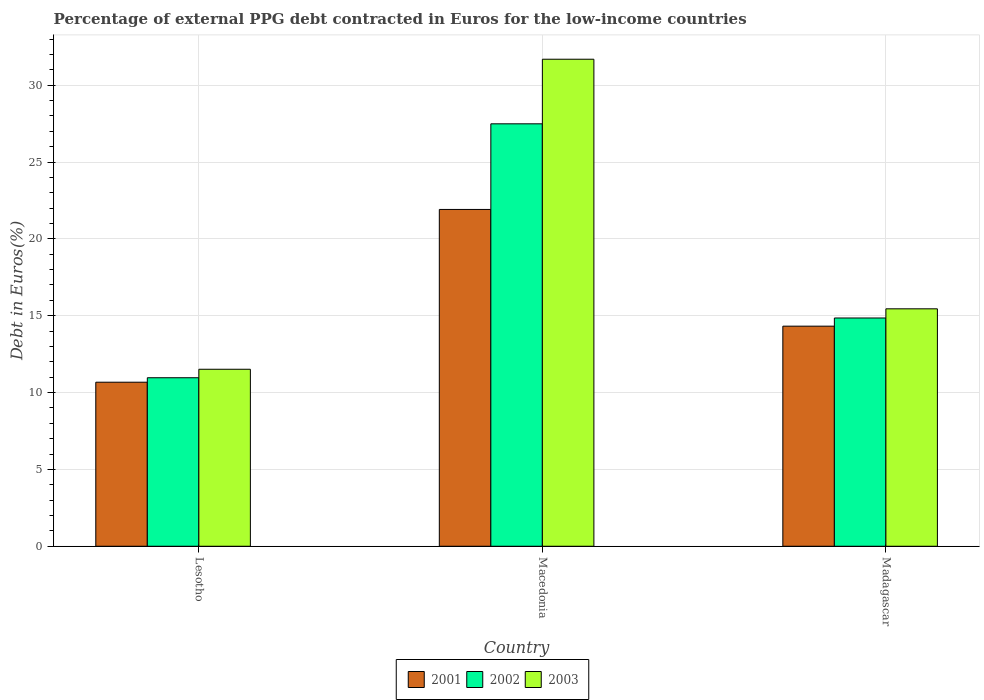How many bars are there on the 2nd tick from the left?
Keep it short and to the point. 3. What is the label of the 3rd group of bars from the left?
Make the answer very short. Madagascar. In how many cases, is the number of bars for a given country not equal to the number of legend labels?
Offer a very short reply. 0. What is the percentage of external PPG debt contracted in Euros in 2003 in Madagascar?
Your answer should be compact. 15.45. Across all countries, what is the maximum percentage of external PPG debt contracted in Euros in 2003?
Your answer should be very brief. 31.69. Across all countries, what is the minimum percentage of external PPG debt contracted in Euros in 2001?
Offer a very short reply. 10.67. In which country was the percentage of external PPG debt contracted in Euros in 2002 maximum?
Keep it short and to the point. Macedonia. In which country was the percentage of external PPG debt contracted in Euros in 2002 minimum?
Keep it short and to the point. Lesotho. What is the total percentage of external PPG debt contracted in Euros in 2002 in the graph?
Provide a succinct answer. 53.3. What is the difference between the percentage of external PPG debt contracted in Euros in 2003 in Lesotho and that in Macedonia?
Offer a terse response. -20.17. What is the difference between the percentage of external PPG debt contracted in Euros in 2001 in Lesotho and the percentage of external PPG debt contracted in Euros in 2003 in Madagascar?
Ensure brevity in your answer.  -4.78. What is the average percentage of external PPG debt contracted in Euros in 2001 per country?
Give a very brief answer. 15.64. What is the difference between the percentage of external PPG debt contracted in Euros of/in 2002 and percentage of external PPG debt contracted in Euros of/in 2001 in Lesotho?
Provide a succinct answer. 0.29. What is the ratio of the percentage of external PPG debt contracted in Euros in 2003 in Lesotho to that in Macedonia?
Offer a very short reply. 0.36. What is the difference between the highest and the second highest percentage of external PPG debt contracted in Euros in 2002?
Make the answer very short. -16.52. What is the difference between the highest and the lowest percentage of external PPG debt contracted in Euros in 2002?
Offer a very short reply. 16.52. In how many countries, is the percentage of external PPG debt contracted in Euros in 2001 greater than the average percentage of external PPG debt contracted in Euros in 2001 taken over all countries?
Your response must be concise. 1. Is the sum of the percentage of external PPG debt contracted in Euros in 2002 in Lesotho and Madagascar greater than the maximum percentage of external PPG debt contracted in Euros in 2003 across all countries?
Ensure brevity in your answer.  No. What does the 1st bar from the left in Macedonia represents?
Your response must be concise. 2001. How many bars are there?
Ensure brevity in your answer.  9. Are all the bars in the graph horizontal?
Provide a short and direct response. No. How many countries are there in the graph?
Your answer should be very brief. 3. What is the difference between two consecutive major ticks on the Y-axis?
Make the answer very short. 5. Are the values on the major ticks of Y-axis written in scientific E-notation?
Ensure brevity in your answer.  No. Does the graph contain any zero values?
Provide a succinct answer. No. How many legend labels are there?
Keep it short and to the point. 3. How are the legend labels stacked?
Your answer should be very brief. Horizontal. What is the title of the graph?
Keep it short and to the point. Percentage of external PPG debt contracted in Euros for the low-income countries. Does "2015" appear as one of the legend labels in the graph?
Keep it short and to the point. No. What is the label or title of the X-axis?
Provide a succinct answer. Country. What is the label or title of the Y-axis?
Give a very brief answer. Debt in Euros(%). What is the Debt in Euros(%) in 2001 in Lesotho?
Your answer should be compact. 10.67. What is the Debt in Euros(%) of 2002 in Lesotho?
Provide a succinct answer. 10.96. What is the Debt in Euros(%) of 2003 in Lesotho?
Make the answer very short. 11.52. What is the Debt in Euros(%) in 2001 in Macedonia?
Keep it short and to the point. 21.92. What is the Debt in Euros(%) in 2002 in Macedonia?
Keep it short and to the point. 27.49. What is the Debt in Euros(%) in 2003 in Macedonia?
Provide a short and direct response. 31.69. What is the Debt in Euros(%) of 2001 in Madagascar?
Provide a short and direct response. 14.32. What is the Debt in Euros(%) in 2002 in Madagascar?
Your answer should be compact. 14.85. What is the Debt in Euros(%) of 2003 in Madagascar?
Give a very brief answer. 15.45. Across all countries, what is the maximum Debt in Euros(%) of 2001?
Give a very brief answer. 21.92. Across all countries, what is the maximum Debt in Euros(%) in 2002?
Your answer should be compact. 27.49. Across all countries, what is the maximum Debt in Euros(%) in 2003?
Offer a terse response. 31.69. Across all countries, what is the minimum Debt in Euros(%) of 2001?
Your response must be concise. 10.67. Across all countries, what is the minimum Debt in Euros(%) of 2002?
Your answer should be very brief. 10.96. Across all countries, what is the minimum Debt in Euros(%) of 2003?
Offer a terse response. 11.52. What is the total Debt in Euros(%) of 2001 in the graph?
Your answer should be very brief. 46.91. What is the total Debt in Euros(%) of 2002 in the graph?
Your response must be concise. 53.3. What is the total Debt in Euros(%) in 2003 in the graph?
Make the answer very short. 58.66. What is the difference between the Debt in Euros(%) in 2001 in Lesotho and that in Macedonia?
Offer a terse response. -11.24. What is the difference between the Debt in Euros(%) in 2002 in Lesotho and that in Macedonia?
Offer a very short reply. -16.52. What is the difference between the Debt in Euros(%) of 2003 in Lesotho and that in Macedonia?
Keep it short and to the point. -20.17. What is the difference between the Debt in Euros(%) of 2001 in Lesotho and that in Madagascar?
Your answer should be compact. -3.65. What is the difference between the Debt in Euros(%) in 2002 in Lesotho and that in Madagascar?
Keep it short and to the point. -3.89. What is the difference between the Debt in Euros(%) in 2003 in Lesotho and that in Madagascar?
Make the answer very short. -3.93. What is the difference between the Debt in Euros(%) of 2001 in Macedonia and that in Madagascar?
Provide a succinct answer. 7.59. What is the difference between the Debt in Euros(%) in 2002 in Macedonia and that in Madagascar?
Your answer should be very brief. 12.63. What is the difference between the Debt in Euros(%) in 2003 in Macedonia and that in Madagascar?
Make the answer very short. 16.24. What is the difference between the Debt in Euros(%) in 2001 in Lesotho and the Debt in Euros(%) in 2002 in Macedonia?
Offer a terse response. -16.81. What is the difference between the Debt in Euros(%) in 2001 in Lesotho and the Debt in Euros(%) in 2003 in Macedonia?
Your answer should be very brief. -21.02. What is the difference between the Debt in Euros(%) of 2002 in Lesotho and the Debt in Euros(%) of 2003 in Macedonia?
Your answer should be compact. -20.73. What is the difference between the Debt in Euros(%) in 2001 in Lesotho and the Debt in Euros(%) in 2002 in Madagascar?
Ensure brevity in your answer.  -4.18. What is the difference between the Debt in Euros(%) in 2001 in Lesotho and the Debt in Euros(%) in 2003 in Madagascar?
Ensure brevity in your answer.  -4.78. What is the difference between the Debt in Euros(%) in 2002 in Lesotho and the Debt in Euros(%) in 2003 in Madagascar?
Your answer should be very brief. -4.48. What is the difference between the Debt in Euros(%) of 2001 in Macedonia and the Debt in Euros(%) of 2002 in Madagascar?
Your answer should be very brief. 7.06. What is the difference between the Debt in Euros(%) in 2001 in Macedonia and the Debt in Euros(%) in 2003 in Madagascar?
Your answer should be very brief. 6.47. What is the difference between the Debt in Euros(%) in 2002 in Macedonia and the Debt in Euros(%) in 2003 in Madagascar?
Provide a short and direct response. 12.04. What is the average Debt in Euros(%) in 2001 per country?
Make the answer very short. 15.64. What is the average Debt in Euros(%) in 2002 per country?
Give a very brief answer. 17.77. What is the average Debt in Euros(%) in 2003 per country?
Give a very brief answer. 19.55. What is the difference between the Debt in Euros(%) of 2001 and Debt in Euros(%) of 2002 in Lesotho?
Offer a very short reply. -0.29. What is the difference between the Debt in Euros(%) of 2001 and Debt in Euros(%) of 2003 in Lesotho?
Keep it short and to the point. -0.84. What is the difference between the Debt in Euros(%) in 2002 and Debt in Euros(%) in 2003 in Lesotho?
Offer a terse response. -0.55. What is the difference between the Debt in Euros(%) of 2001 and Debt in Euros(%) of 2002 in Macedonia?
Provide a short and direct response. -5.57. What is the difference between the Debt in Euros(%) of 2001 and Debt in Euros(%) of 2003 in Macedonia?
Keep it short and to the point. -9.77. What is the difference between the Debt in Euros(%) of 2002 and Debt in Euros(%) of 2003 in Macedonia?
Give a very brief answer. -4.2. What is the difference between the Debt in Euros(%) in 2001 and Debt in Euros(%) in 2002 in Madagascar?
Make the answer very short. -0.53. What is the difference between the Debt in Euros(%) of 2001 and Debt in Euros(%) of 2003 in Madagascar?
Your answer should be very brief. -1.13. What is the difference between the Debt in Euros(%) of 2002 and Debt in Euros(%) of 2003 in Madagascar?
Your response must be concise. -0.6. What is the ratio of the Debt in Euros(%) of 2001 in Lesotho to that in Macedonia?
Your response must be concise. 0.49. What is the ratio of the Debt in Euros(%) in 2002 in Lesotho to that in Macedonia?
Make the answer very short. 0.4. What is the ratio of the Debt in Euros(%) in 2003 in Lesotho to that in Macedonia?
Make the answer very short. 0.36. What is the ratio of the Debt in Euros(%) of 2001 in Lesotho to that in Madagascar?
Provide a succinct answer. 0.75. What is the ratio of the Debt in Euros(%) of 2002 in Lesotho to that in Madagascar?
Offer a terse response. 0.74. What is the ratio of the Debt in Euros(%) in 2003 in Lesotho to that in Madagascar?
Give a very brief answer. 0.75. What is the ratio of the Debt in Euros(%) in 2001 in Macedonia to that in Madagascar?
Ensure brevity in your answer.  1.53. What is the ratio of the Debt in Euros(%) of 2002 in Macedonia to that in Madagascar?
Make the answer very short. 1.85. What is the ratio of the Debt in Euros(%) of 2003 in Macedonia to that in Madagascar?
Give a very brief answer. 2.05. What is the difference between the highest and the second highest Debt in Euros(%) of 2001?
Ensure brevity in your answer.  7.59. What is the difference between the highest and the second highest Debt in Euros(%) of 2002?
Your response must be concise. 12.63. What is the difference between the highest and the second highest Debt in Euros(%) in 2003?
Provide a short and direct response. 16.24. What is the difference between the highest and the lowest Debt in Euros(%) of 2001?
Give a very brief answer. 11.24. What is the difference between the highest and the lowest Debt in Euros(%) in 2002?
Provide a short and direct response. 16.52. What is the difference between the highest and the lowest Debt in Euros(%) in 2003?
Provide a succinct answer. 20.17. 